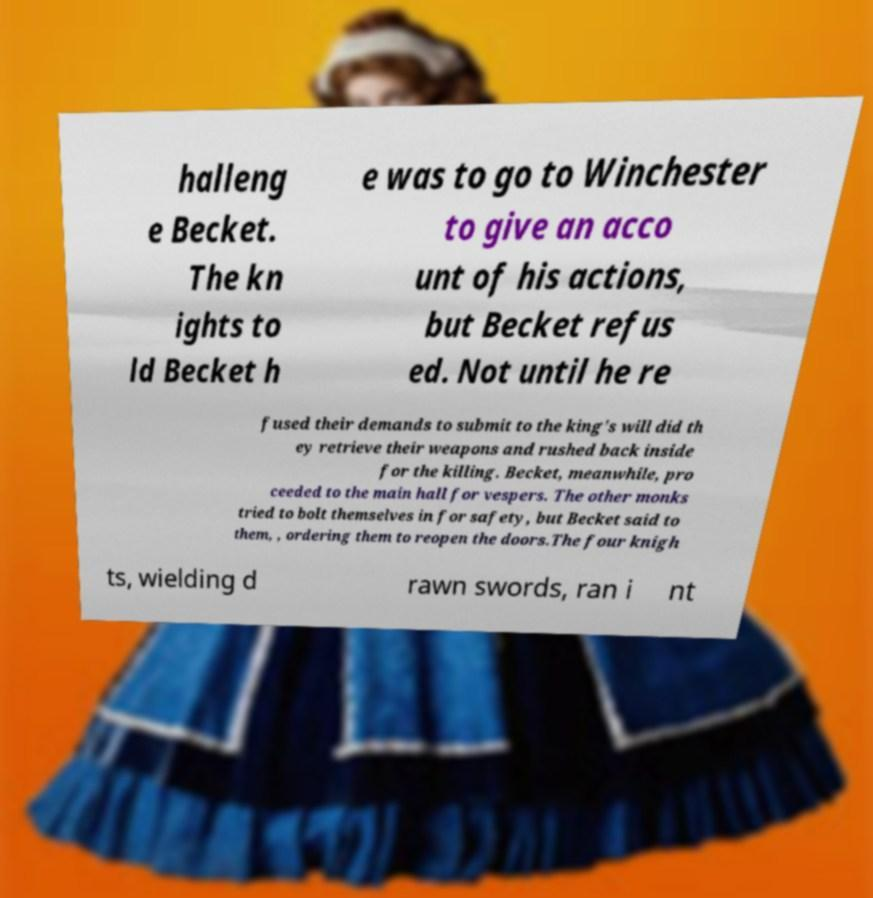Please read and relay the text visible in this image. What does it say? halleng e Becket. The kn ights to ld Becket h e was to go to Winchester to give an acco unt of his actions, but Becket refus ed. Not until he re fused their demands to submit to the king's will did th ey retrieve their weapons and rushed back inside for the killing. Becket, meanwhile, pro ceeded to the main hall for vespers. The other monks tried to bolt themselves in for safety, but Becket said to them, , ordering them to reopen the doors.The four knigh ts, wielding d rawn swords, ran i nt 